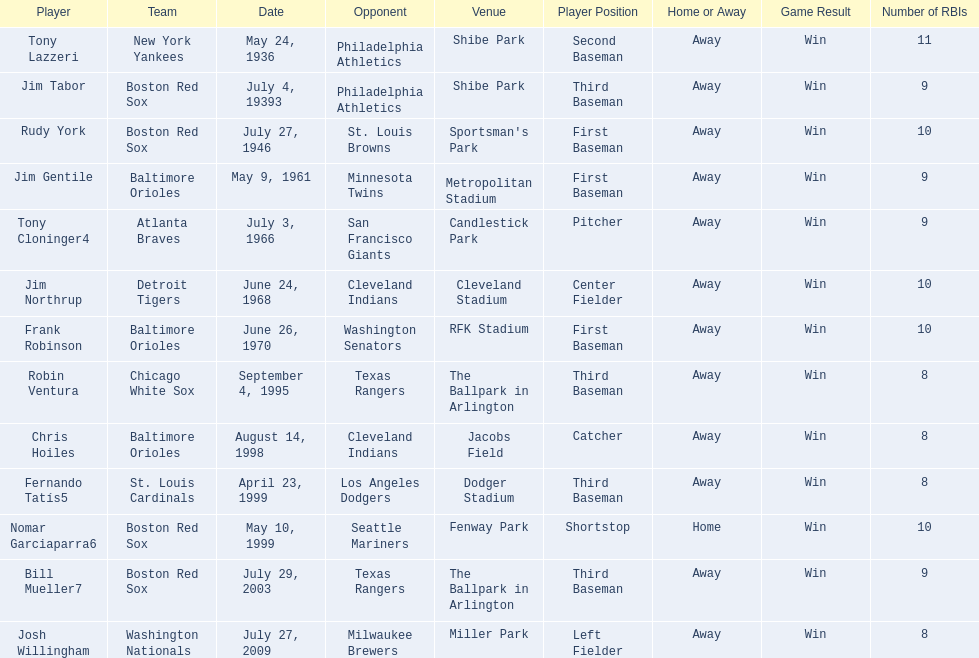Who were all of the players? Tony Lazzeri, Jim Tabor, Rudy York, Jim Gentile, Tony Cloninger4, Jim Northrup, Frank Robinson, Robin Ventura, Chris Hoiles, Fernando Tatís5, Nomar Garciaparra6, Bill Mueller7, Josh Willingham. What year was there a player for the yankees? May 24, 1936. What was the name of that 1936 yankees player? Tony Lazzeri. 